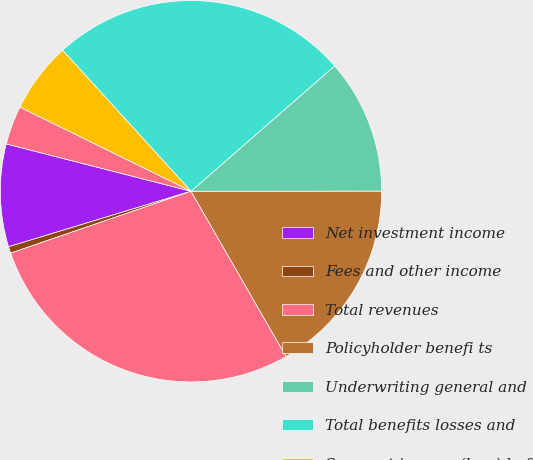Convert chart to OTSL. <chart><loc_0><loc_0><loc_500><loc_500><pie_chart><fcel>Net investment income<fcel>Fees and other income<fcel>Total revenues<fcel>Policyholder benefi ts<fcel>Underwriting general and<fcel>Total benefits losses and<fcel>Segment income (loss) before<fcel>Provision (benefit) for income<nl><fcel>8.69%<fcel>0.56%<fcel>28.04%<fcel>16.7%<fcel>11.4%<fcel>25.33%<fcel>5.98%<fcel>3.27%<nl></chart> 